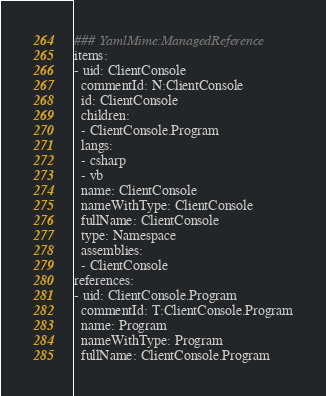Convert code to text. <code><loc_0><loc_0><loc_500><loc_500><_YAML_>### YamlMime:ManagedReference
items:
- uid: ClientConsole
  commentId: N:ClientConsole
  id: ClientConsole
  children:
  - ClientConsole.Program
  langs:
  - csharp
  - vb
  name: ClientConsole
  nameWithType: ClientConsole
  fullName: ClientConsole
  type: Namespace
  assemblies:
  - ClientConsole
references:
- uid: ClientConsole.Program
  commentId: T:ClientConsole.Program
  name: Program
  nameWithType: Program
  fullName: ClientConsole.Program
</code> 